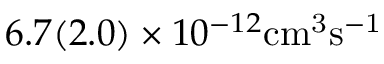Convert formula to latex. <formula><loc_0><loc_0><loc_500><loc_500>6 . 7 ( 2 . 0 ) \times 1 0 ^ { - 1 2 } { c m } ^ { 3 } \mathrm { { s } ^ { - 1 } }</formula> 